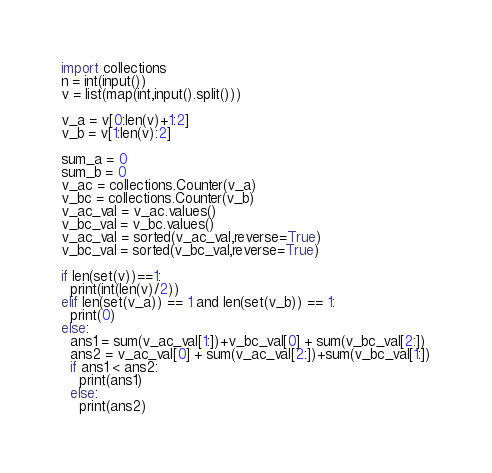Convert code to text. <code><loc_0><loc_0><loc_500><loc_500><_Python_>import collections
n = int(input())
v = list(map(int,input().split()))

v_a = v[0:len(v)+1:2]
v_b = v[1:len(v):2]

sum_a = 0
sum_b = 0
v_ac = collections.Counter(v_a)
v_bc = collections.Counter(v_b)
v_ac_val = v_ac.values()
v_bc_val = v_bc.values()
v_ac_val = sorted(v_ac_val,reverse=True)
v_bc_val = sorted(v_bc_val,reverse=True)

if len(set(v))==1:
  print(int(len(v)/2))
elif len(set(v_a)) == 1 and len(set(v_b)) == 1:
  print(0)
else:
  ans1 = sum(v_ac_val[1:])+v_bc_val[0] + sum(v_bc_val[2:])
  ans2 = v_ac_val[0] + sum(v_ac_val[2:])+sum(v_bc_val[1:])
  if ans1 < ans2:
    print(ans1)
  else:
    print(ans2)</code> 